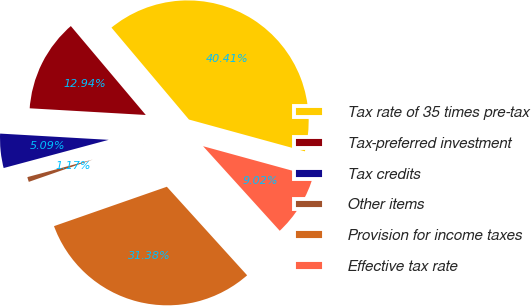<chart> <loc_0><loc_0><loc_500><loc_500><pie_chart><fcel>Tax rate of 35 times pre-tax<fcel>Tax-preferred investment<fcel>Tax credits<fcel>Other items<fcel>Provision for income taxes<fcel>Effective tax rate<nl><fcel>40.41%<fcel>12.94%<fcel>5.09%<fcel>1.17%<fcel>31.38%<fcel>9.02%<nl></chart> 